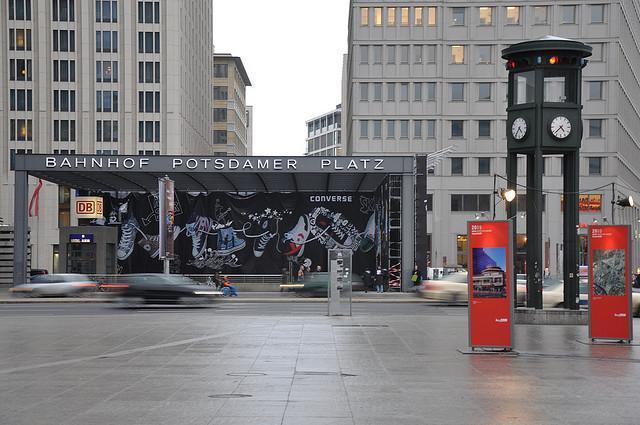How many red stands?
Give a very brief answer. 2. How many clocks are in the picture?
Give a very brief answer. 2. How many motorcycles are on the road?
Give a very brief answer. 0. 